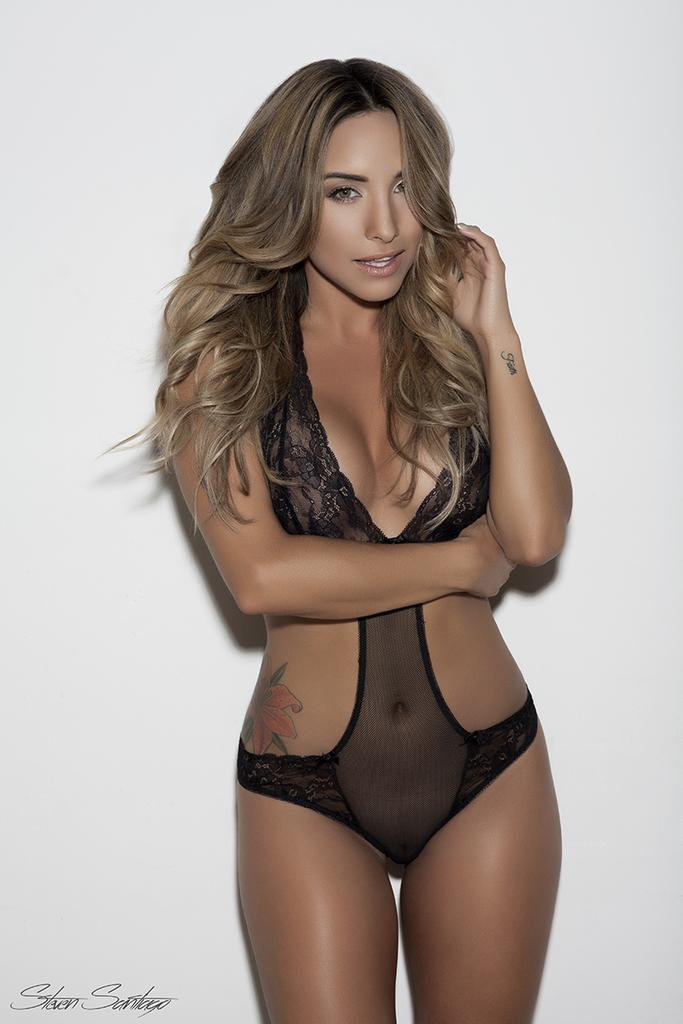Who is the main subject in the image? There is a woman in the image. What color is the woman wearing? The woman is wearing black. What is the woman doing in the image? The woman is standing. What color is the background of the image? The background of the image is white. What type of nut is the woman holding in the image? There is no nut present in the image; the woman is not holding anything. Can you tell me how many men are visible in the image? There are no men visible in the image; only the woman is present. 